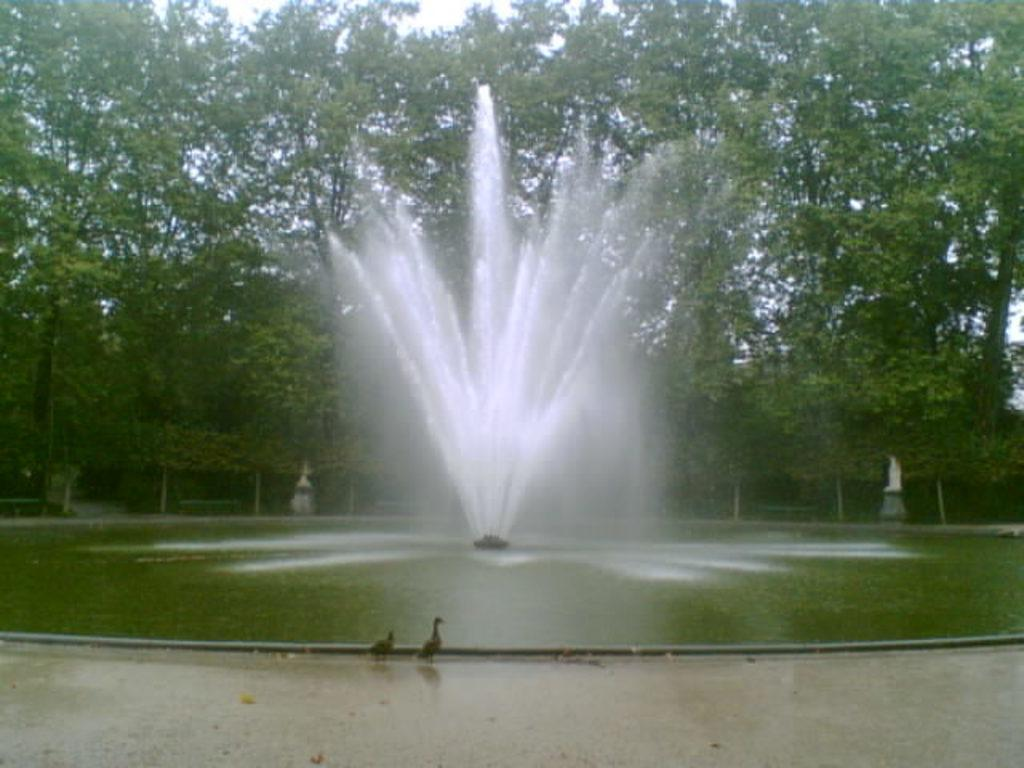What is located in the foreground of the image? There is a water pool in the foreground of the image. What feature is present within the water pool? There is a fountain in the water pool. Are there any animals visible in the image? Yes, there are two birds on the side of the water pool. What can be seen in the background of the image? There are trees visible in the background of the image. What type of marble can be seen in the image? There is no marble present in the image. Is the cemetery visible in the background of the image? No, the image does not show a cemetery; it features trees in the background. 